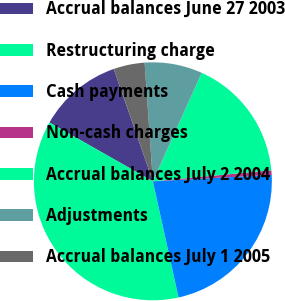Convert chart to OTSL. <chart><loc_0><loc_0><loc_500><loc_500><pie_chart><fcel>Accrual balances June 27 2003<fcel>Restructuring charge<fcel>Cash payments<fcel>Non-cash charges<fcel>Accrual balances July 2 2004<fcel>Adjustments<fcel>Accrual balances July 1 2005<nl><fcel>11.44%<fcel>36.69%<fcel>22.39%<fcel>0.62%<fcel>16.79%<fcel>7.84%<fcel>4.23%<nl></chart> 